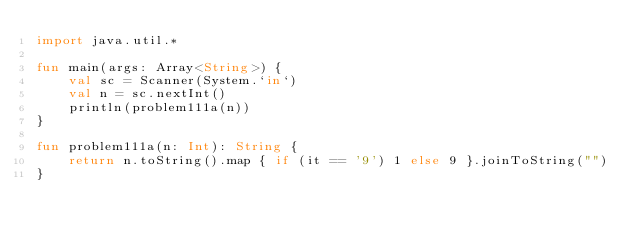Convert code to text. <code><loc_0><loc_0><loc_500><loc_500><_Kotlin_>import java.util.*

fun main(args: Array<String>) {
    val sc = Scanner(System.`in`)
    val n = sc.nextInt()
    println(problem111a(n))
}

fun problem111a(n: Int): String {
    return n.toString().map { if (it == '9') 1 else 9 }.joinToString("")
}</code> 